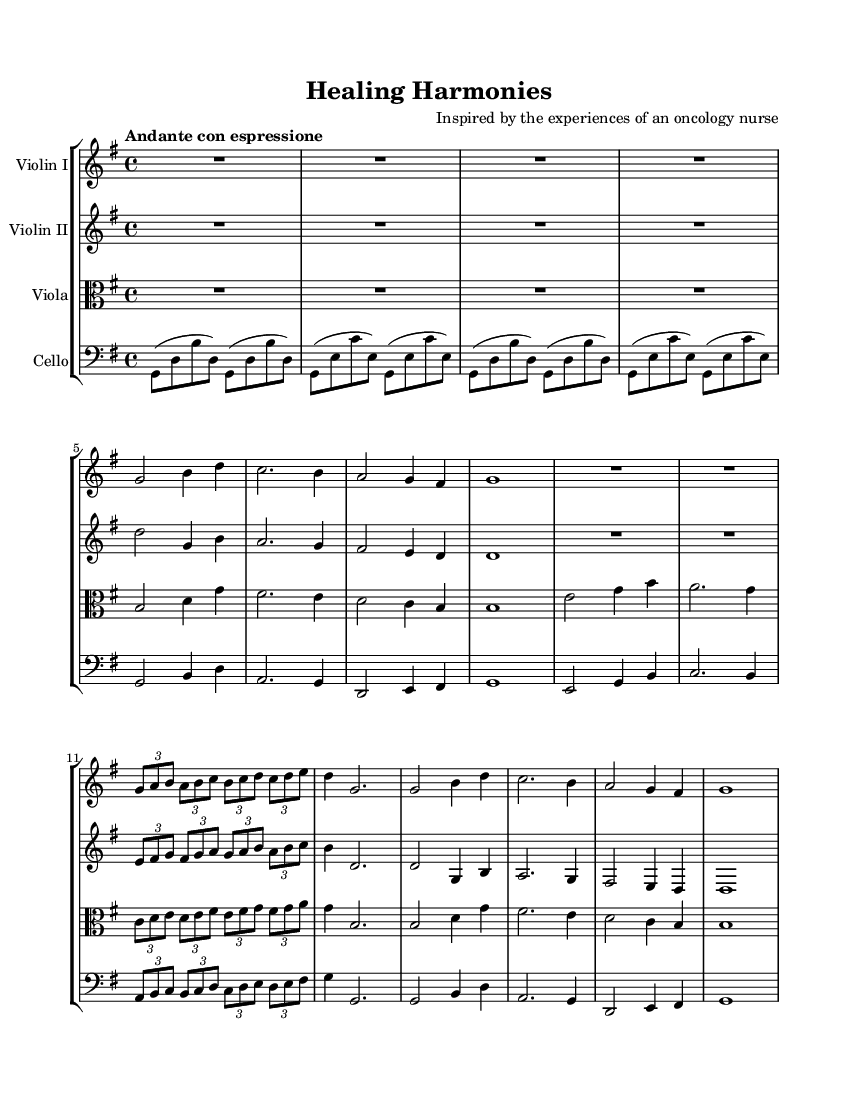What is the key signature of this music? The key signature is G major, which has one sharp (F#). This can be identified by looking at the beginning of the staff, where the sharps are indicated.
Answer: G major What is the time signature of the piece? The time signature is 4/4, which means there are four beats in each measure and the quarter note gets one beat. This information is typically found at the beginning of the piece, notated after the key signature.
Answer: 4/4 What is the tempo marking for this piece? The tempo marking is "Andante con espressione," indicating a moderate pace with expression. This is generally placed above the staff near the beginning of the score.
Answer: Andante con espressione How many measures are in the first theme (Theme A)? Theme A consists of 4 measures. By counting the measures from the music notation provided in the score, we can determine this.
Answer: 4 measures What instruments are involved in this string quartet? The instruments in this string quartet are Violin I, Violin II, Viola, and Cello. This information is usually indicated at the beginning of each staff in the score.
Answer: Violin I, Violin II, Viola, Cello What two musical concepts are emphasized in this piece based on its themes? The musical concepts emphasized are hope and perseverance. This conclusion is drawn from the title "Healing Harmonies" and the context that the piece is inspired by an oncology nurse's experiences, portraying emotional themes.
Answer: Hope, perseverance What note does the first theme (Theme A) start on for Violin I? The first theme starts on the note G. This can be seen in the very first measure of the Violin I part, identifying the pitch indicated in the notation.
Answer: G 